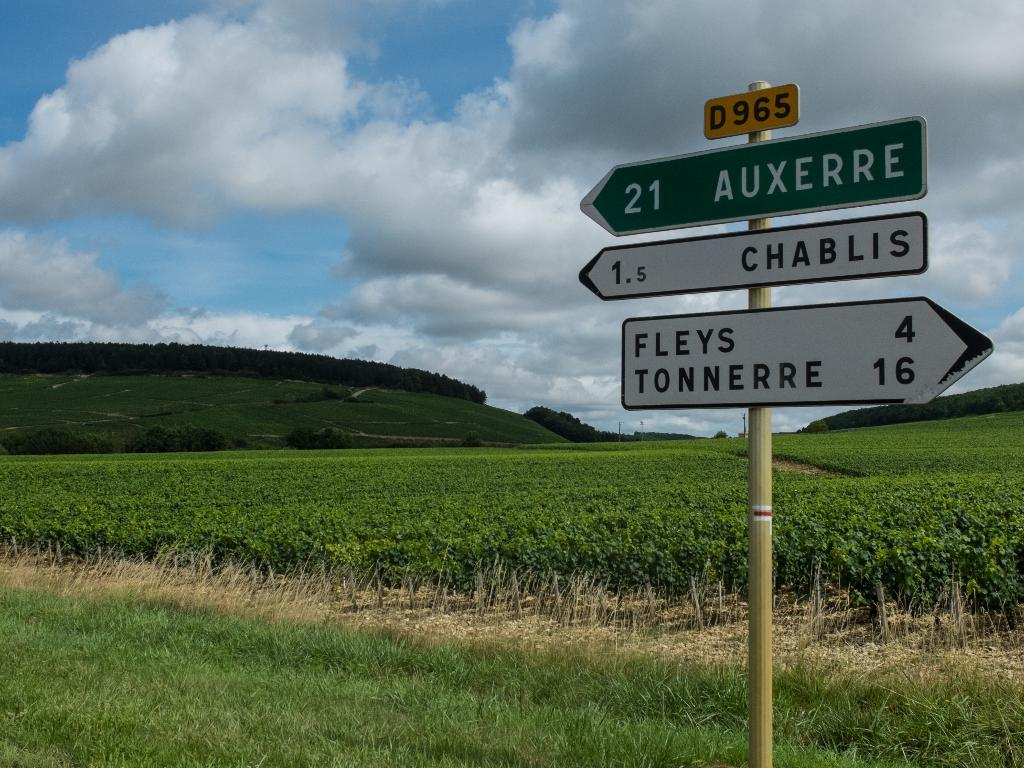What type of landscape is depicted in the image? The image features fields. Are there any man-made structures visible in the image? Yes, there are sign boards in the image. What is the ground covered with in the image? The ground is covered with grass. What can be seen in the distance in the image? There is a mountain in the background of the image. What is visible in the sky at the top of the image? There are clouds in the sky at the top of the image. What type of vacation is being advertised on the carriage in the image? There is no carriage present in the image, so it is not possible to determine what type of vacation might be advertised. 